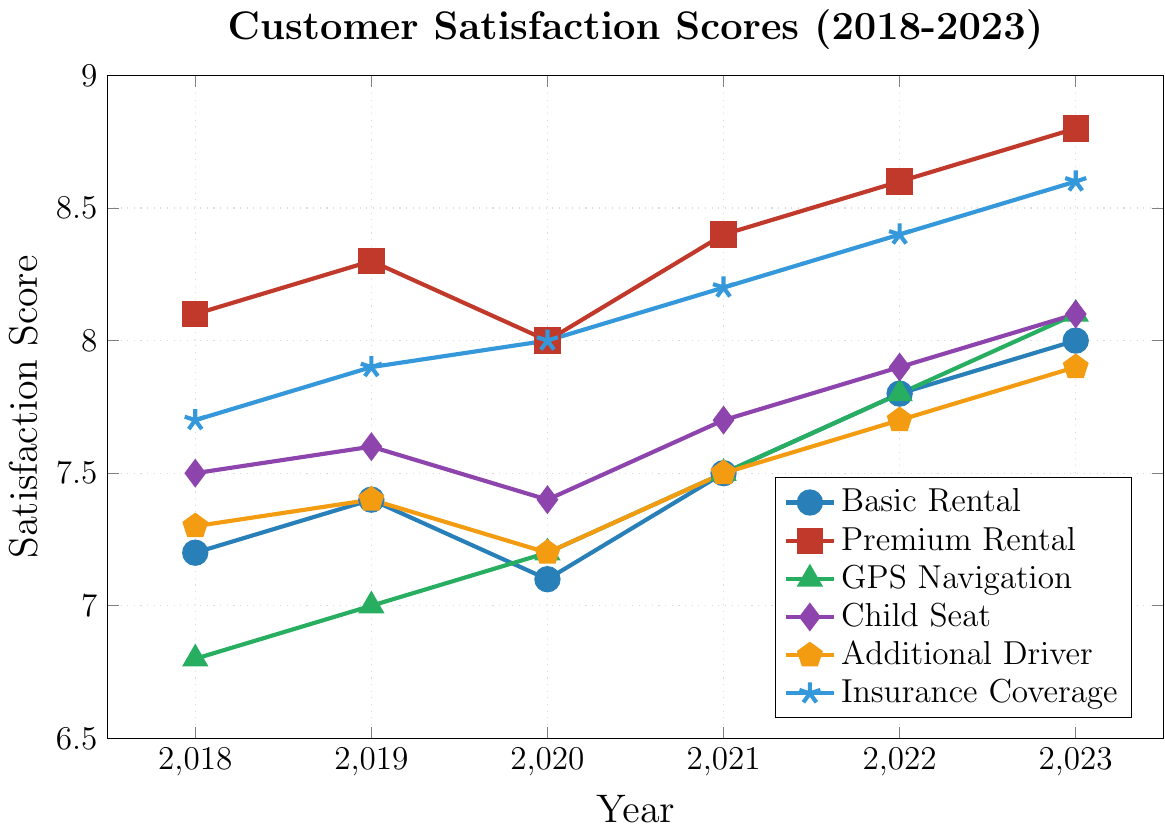What is the trend for the Basic Rental satisfaction scores from 2018 to 2023? The Basic Rental satisfaction scores show an overall increasing trend. Starting from 7.2 in 2018, it slightly dips to 7.1 in 2020 but then consistently rises each year to reach 8.0 in 2023.
Answer: Increasing Which rental service has seen the greatest increase in customer satisfaction from 2018 to 2023? To determine this, subtract the 2018 satisfaction score from the 2023 satisfaction score for each service. Basic Rental: 8.0 - 7.2 = 0.8, Premium Rental: 8.8 - 8.1 = 0.7, GPS Navigation: 8.1 - 6.8 = 1.3, Child Seat: 8.1 - 7.5 = 0.6, Additional Driver: 7.9 - 7.3 = 0.6, Insurance Coverage: 8.6 - 7.7 = 0.9. GPS Navigation has the greatest increase at 1.3.
Answer: GPS Navigation How does the satisfaction score of GPS Navigation in 2021 compare to the satisfaction score of Insurance Coverage in 2019? The satisfaction score for GPS Navigation in 2021 is 7.5, while for Insurance Coverage in 2019 it is 7.9. Comparing these, Insurance Coverage in 2019 has a higher score.
Answer: Insurance Coverage in 2019 is higher What is the average satisfaction score for Premium Rental from 2018 to 2023? To find the average, sum the scores from 2018 to 2023 and divide by the number of years: (8.1 + 8.3 + 8.0 + 8.4 + 8.6 + 8.8) / 6 = 8.36.
Answer: 8.36 Identify the year where Child Seat satisfaction score was the lowest and state the score. To find the lowest score for Child Seat, check all years: 2018: 7.5, 2019: 7.6, 2020: 7.4, 2021: 7.7, 2022: 7.9, 2023: 8.1. The lowest score is 7.4 in 2020.
Answer: 2020, 7.4 Visualize the color associated with the Insurance Coverage line and how it stands out compared to the others. The Insurance Coverage line is represented by the color blue and is marked with a star. This color stands out prominently against other colors like green for GPS Navigation and red for Premium Rental.
Answer: Blue, star-shaped If we combine the satisfaction trends of Additional Driver and Child Seat in 2023, what is their average score? The satisfaction scores for Additional Driver and Child Seat in 2023 are 7.9 and 8.1 respectively. To find the average: (7.9 + 8.1) / 2 = 8.0.
Answer: 8.0 